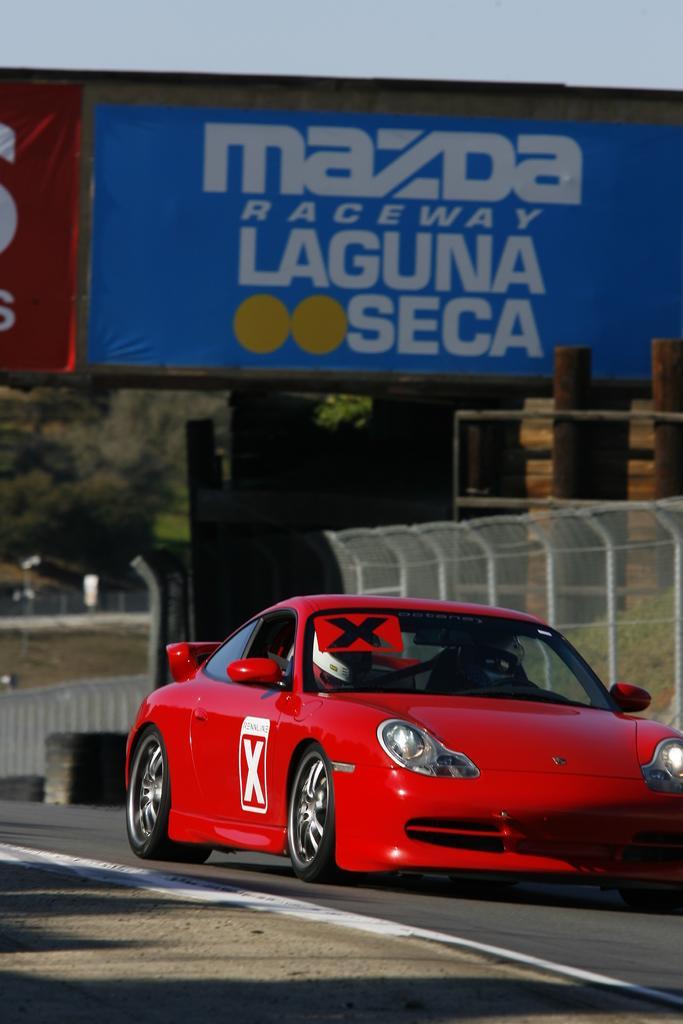How would you summarize this image in a sentence or two? In this picture we can see a person is sitting in a red car and the car is on the road. Behind the car there is the fence, hoarding, trees and the sky. 